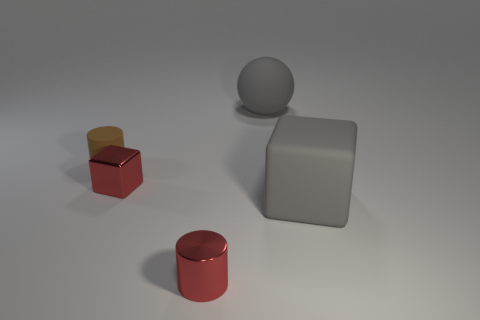There is a cylinder that is the same color as the shiny cube; what size is it?
Your answer should be very brief. Small. Is there another object of the same shape as the tiny brown rubber object?
Your answer should be very brief. Yes. How many objects are shiny cylinders or objects right of the tiny metallic cylinder?
Offer a terse response. 3. What color is the cube that is on the left side of the large rubber block?
Make the answer very short. Red. There is a cylinder that is in front of the big gray block; does it have the same size as the cube on the left side of the red metal cylinder?
Offer a terse response. Yes. Are there any brown balls of the same size as the shiny cube?
Your answer should be compact. No. How many big gray rubber things are behind the cube that is right of the tiny shiny cylinder?
Provide a short and direct response. 1. What is the material of the small red cylinder?
Provide a short and direct response. Metal. There is a big matte cube; how many gray things are behind it?
Give a very brief answer. 1. Do the small shiny cube and the rubber cube have the same color?
Your answer should be very brief. No. 